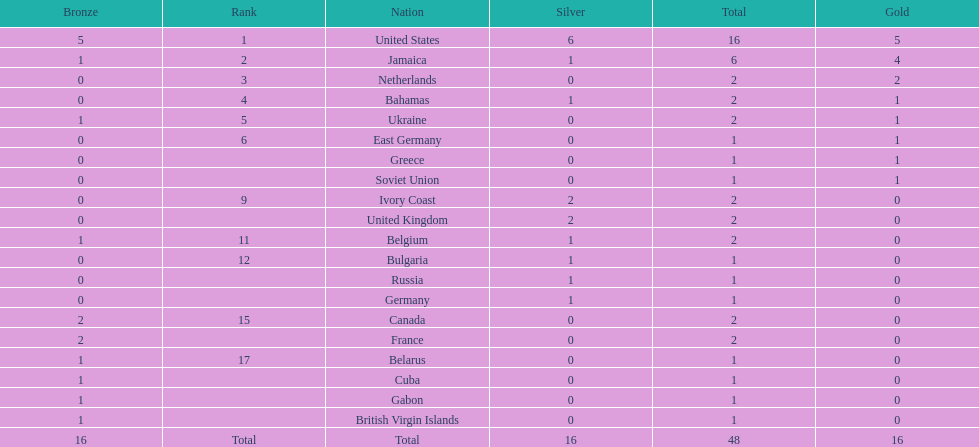What is the total number of gold medals won by jamaica? 4. 